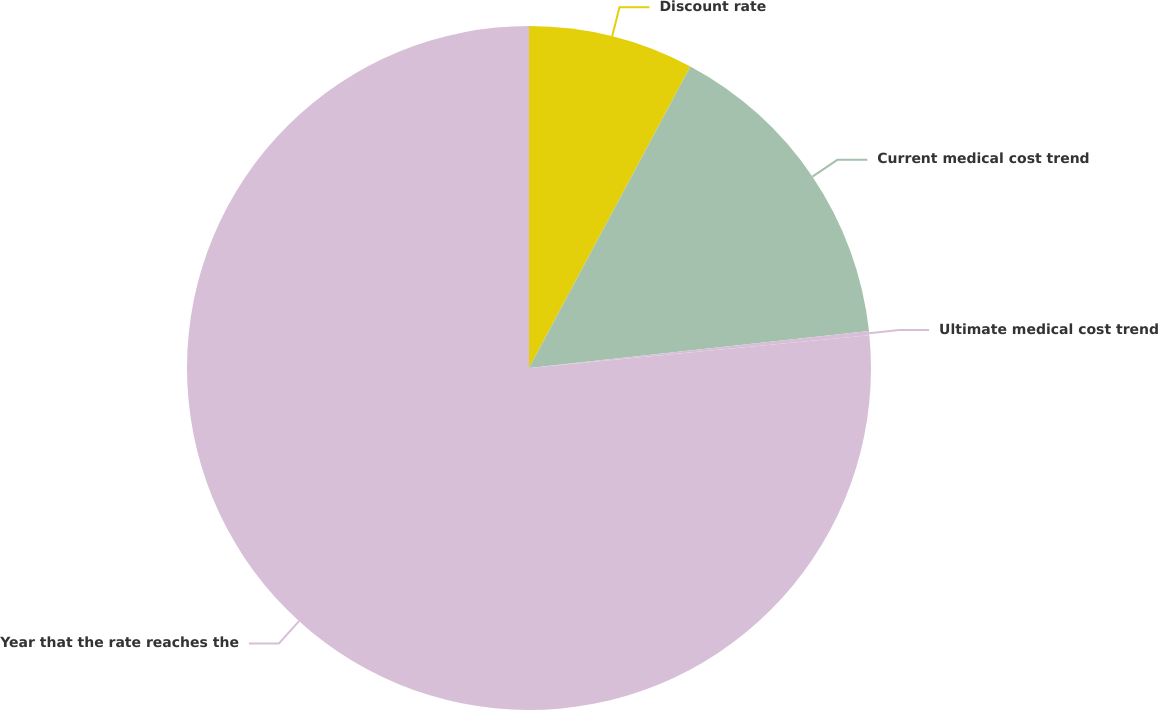Convert chart to OTSL. <chart><loc_0><loc_0><loc_500><loc_500><pie_chart><fcel>Discount rate<fcel>Current medical cost trend<fcel>Ultimate medical cost trend<fcel>Year that the rate reaches the<nl><fcel>7.82%<fcel>15.46%<fcel>0.19%<fcel>76.53%<nl></chart> 